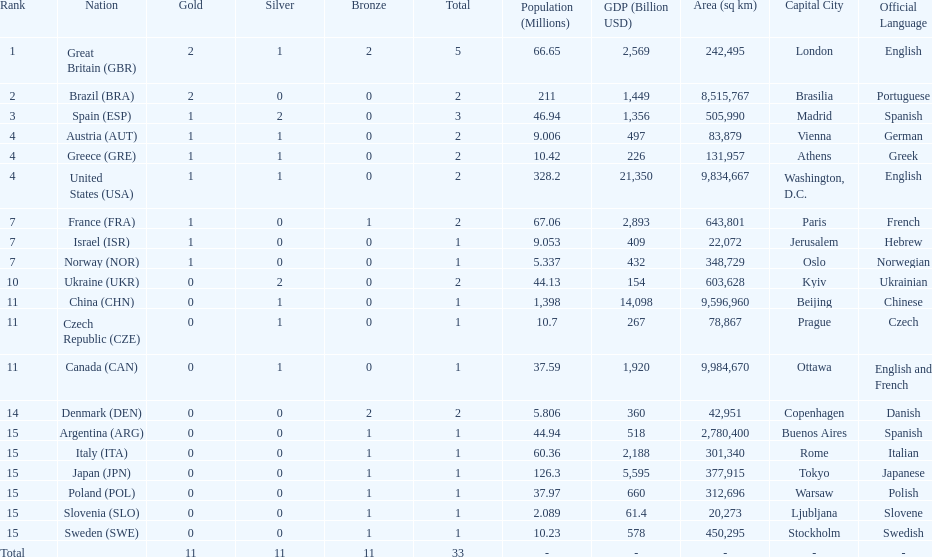How many gold medals did italy receive? 0. Parse the full table. {'header': ['Rank', 'Nation', 'Gold', 'Silver', 'Bronze', 'Total', 'Population (Millions)', 'GDP (Billion USD)', 'Area (sq km)', 'Capital City', 'Official Language'], 'rows': [['1', 'Great Britain\xa0(GBR)', '2', '1', '2', '5', '66.65', '2,569', '242,495', 'London', 'English'], ['2', 'Brazil\xa0(BRA)', '2', '0', '0', '2', '211', '1,449', '8,515,767', 'Brasilia', 'Portuguese'], ['3', 'Spain\xa0(ESP)', '1', '2', '0', '3', '46.94', '1,356', '505,990', 'Madrid', 'Spanish'], ['4', 'Austria\xa0(AUT)', '1', '1', '0', '2', '9.006', '497', '83,879', 'Vienna', 'German'], ['4', 'Greece\xa0(GRE)', '1', '1', '0', '2', '10.42', '226', '131,957', 'Athens', 'Greek'], ['4', 'United States\xa0(USA)', '1', '1', '0', '2', '328.2', '21,350', '9,834,667', 'Washington, D.C.', 'English'], ['7', 'France\xa0(FRA)', '1', '0', '1', '2', '67.06', '2,893', '643,801', 'Paris', 'French'], ['7', 'Israel\xa0(ISR)', '1', '0', '0', '1', '9.053', '409', '22,072', 'Jerusalem', 'Hebrew'], ['7', 'Norway\xa0(NOR)', '1', '0', '0', '1', '5.337', '432', '348,729', 'Oslo', 'Norwegian'], ['10', 'Ukraine\xa0(UKR)', '0', '2', '0', '2', '44.13', '154', '603,628', 'Kyiv', 'Ukrainian'], ['11', 'China\xa0(CHN)', '0', '1', '0', '1', '1,398', '14,098', '9,596,960', 'Beijing', 'Chinese'], ['11', 'Czech Republic\xa0(CZE)', '0', '1', '0', '1', '10.7', '267', '78,867', 'Prague', 'Czech'], ['11', 'Canada\xa0(CAN)', '0', '1', '0', '1', '37.59', '1,920', '9,984,670', 'Ottawa', 'English and French'], ['14', 'Denmark\xa0(DEN)', '0', '0', '2', '2', '5.806', '360', '42,951', 'Copenhagen', 'Danish'], ['15', 'Argentina\xa0(ARG)', '0', '0', '1', '1', '44.94', '518', '2,780,400', 'Buenos Aires', 'Spanish'], ['15', 'Italy\xa0(ITA)', '0', '0', '1', '1', '60.36', '2,188', '301,340', 'Rome', 'Italian'], ['15', 'Japan\xa0(JPN)', '0', '0', '1', '1', '126.3', '5,595', '377,915', 'Tokyo', 'Japanese'], ['15', 'Poland\xa0(POL)', '0', '0', '1', '1', '37.97', '660', '312,696', 'Warsaw', 'Polish'], ['15', 'Slovenia\xa0(SLO)', '0', '0', '1', '1', '2.089', '61.4', '20,273', 'Ljubljana', 'Slovene'], ['15', 'Sweden\xa0(SWE)', '0', '0', '1', '1', '10.23', '578', '450,295', 'Stockholm', 'Swedish'], ['Total', '', '11', '11', '11', '33', '-', '-', '-', '-', '-']]} 